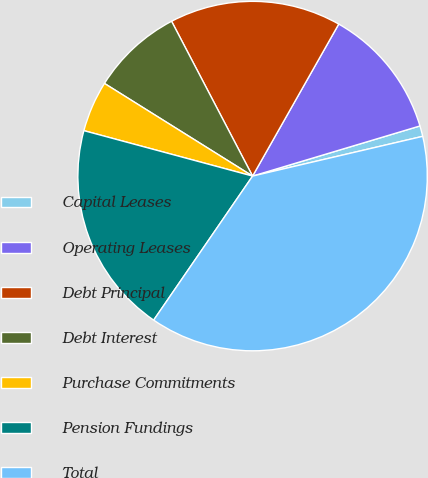Convert chart. <chart><loc_0><loc_0><loc_500><loc_500><pie_chart><fcel>Capital Leases<fcel>Operating Leases<fcel>Debt Principal<fcel>Debt Interest<fcel>Purchase Commitments<fcel>Pension Fundings<fcel>Total<nl><fcel>0.98%<fcel>12.16%<fcel>15.88%<fcel>8.43%<fcel>4.71%<fcel>19.61%<fcel>38.23%<nl></chart> 